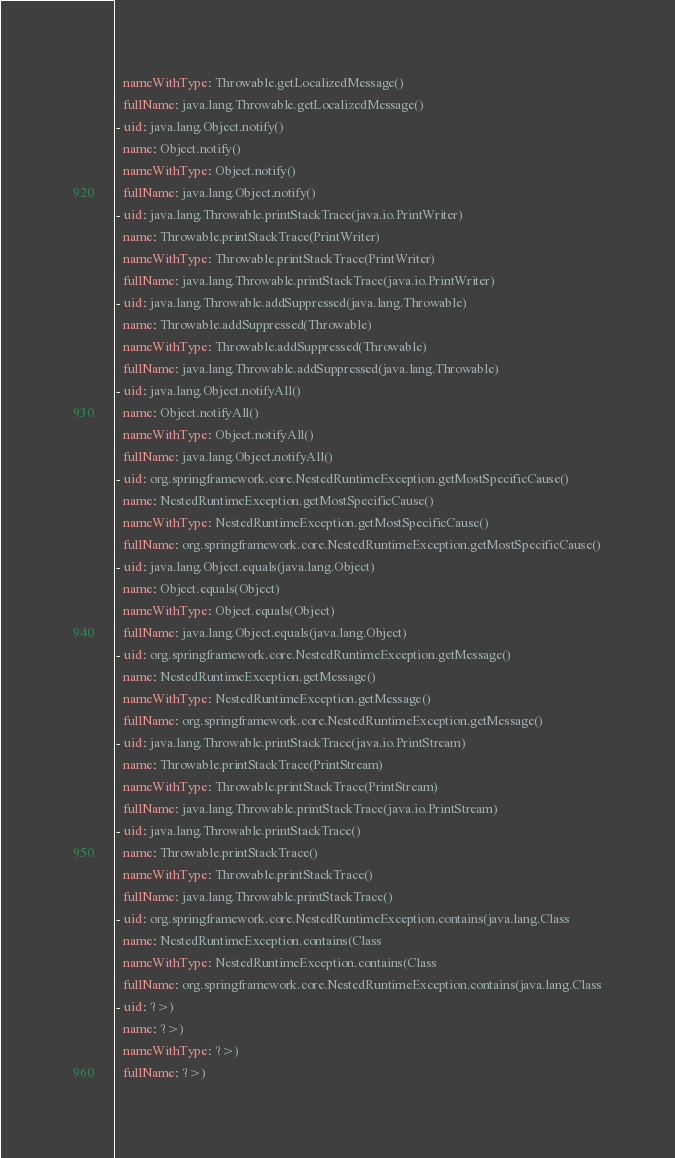<code> <loc_0><loc_0><loc_500><loc_500><_YAML_>  nameWithType: Throwable.getLocalizedMessage()
  fullName: java.lang.Throwable.getLocalizedMessage()
- uid: java.lang.Object.notify()
  name: Object.notify()
  nameWithType: Object.notify()
  fullName: java.lang.Object.notify()
- uid: java.lang.Throwable.printStackTrace(java.io.PrintWriter)
  name: Throwable.printStackTrace(PrintWriter)
  nameWithType: Throwable.printStackTrace(PrintWriter)
  fullName: java.lang.Throwable.printStackTrace(java.io.PrintWriter)
- uid: java.lang.Throwable.addSuppressed(java.lang.Throwable)
  name: Throwable.addSuppressed(Throwable)
  nameWithType: Throwable.addSuppressed(Throwable)
  fullName: java.lang.Throwable.addSuppressed(java.lang.Throwable)
- uid: java.lang.Object.notifyAll()
  name: Object.notifyAll()
  nameWithType: Object.notifyAll()
  fullName: java.lang.Object.notifyAll()
- uid: org.springframework.core.NestedRuntimeException.getMostSpecificCause()
  name: NestedRuntimeException.getMostSpecificCause()
  nameWithType: NestedRuntimeException.getMostSpecificCause()
  fullName: org.springframework.core.NestedRuntimeException.getMostSpecificCause()
- uid: java.lang.Object.equals(java.lang.Object)
  name: Object.equals(Object)
  nameWithType: Object.equals(Object)
  fullName: java.lang.Object.equals(java.lang.Object)
- uid: org.springframework.core.NestedRuntimeException.getMessage()
  name: NestedRuntimeException.getMessage()
  nameWithType: NestedRuntimeException.getMessage()
  fullName: org.springframework.core.NestedRuntimeException.getMessage()
- uid: java.lang.Throwable.printStackTrace(java.io.PrintStream)
  name: Throwable.printStackTrace(PrintStream)
  nameWithType: Throwable.printStackTrace(PrintStream)
  fullName: java.lang.Throwable.printStackTrace(java.io.PrintStream)
- uid: java.lang.Throwable.printStackTrace()
  name: Throwable.printStackTrace()
  nameWithType: Throwable.printStackTrace()
  fullName: java.lang.Throwable.printStackTrace()
- uid: org.springframework.core.NestedRuntimeException.contains(java.lang.Class
  name: NestedRuntimeException.contains(Class
  nameWithType: NestedRuntimeException.contains(Class
  fullName: org.springframework.core.NestedRuntimeException.contains(java.lang.Class
- uid: ?>)
  name: ?>)
  nameWithType: ?>)
  fullName: ?>)
</code> 